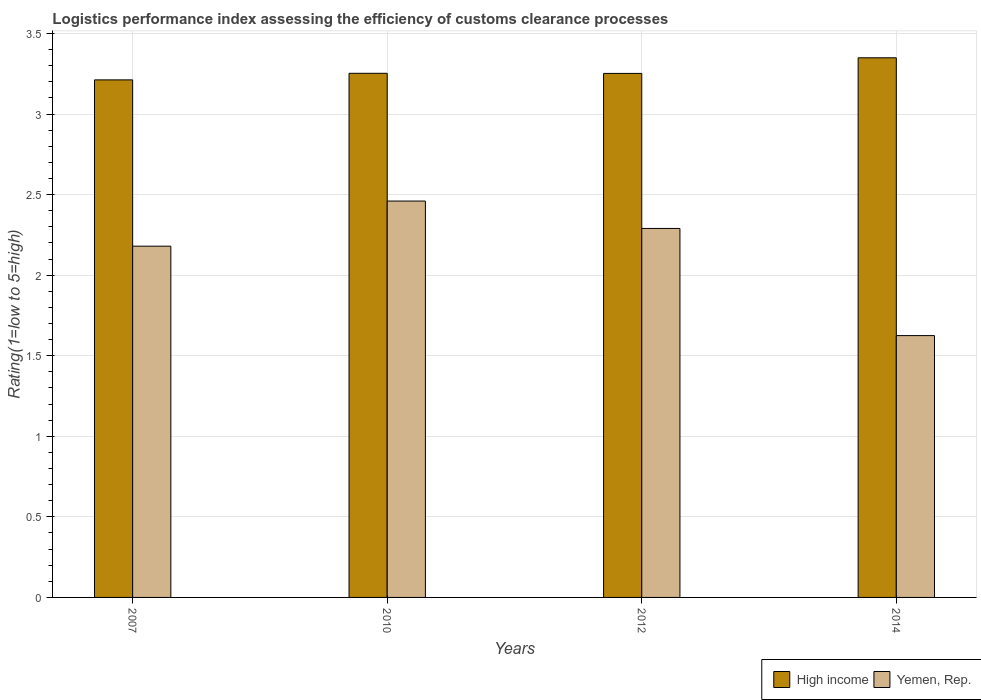How many bars are there on the 1st tick from the right?
Your response must be concise. 2. In how many cases, is the number of bars for a given year not equal to the number of legend labels?
Offer a terse response. 0. What is the Logistic performance index in Yemen, Rep. in 2007?
Offer a very short reply. 2.18. Across all years, what is the maximum Logistic performance index in Yemen, Rep.?
Give a very brief answer. 2.46. Across all years, what is the minimum Logistic performance index in Yemen, Rep.?
Provide a succinct answer. 1.62. In which year was the Logistic performance index in Yemen, Rep. maximum?
Your answer should be compact. 2010. What is the total Logistic performance index in Yemen, Rep. in the graph?
Give a very brief answer. 8.55. What is the difference between the Logistic performance index in Yemen, Rep. in 2010 and that in 2012?
Make the answer very short. 0.17. What is the difference between the Logistic performance index in Yemen, Rep. in 2010 and the Logistic performance index in High income in 2012?
Give a very brief answer. -0.79. What is the average Logistic performance index in High income per year?
Make the answer very short. 3.27. In the year 2014, what is the difference between the Logistic performance index in Yemen, Rep. and Logistic performance index in High income?
Keep it short and to the point. -1.72. What is the ratio of the Logistic performance index in High income in 2007 to that in 2010?
Provide a short and direct response. 0.99. Is the Logistic performance index in Yemen, Rep. in 2007 less than that in 2014?
Provide a succinct answer. No. What is the difference between the highest and the second highest Logistic performance index in High income?
Give a very brief answer. 0.1. What is the difference between the highest and the lowest Logistic performance index in Yemen, Rep.?
Ensure brevity in your answer.  0.83. In how many years, is the Logistic performance index in Yemen, Rep. greater than the average Logistic performance index in Yemen, Rep. taken over all years?
Provide a succinct answer. 3. Is the sum of the Logistic performance index in Yemen, Rep. in 2007 and 2014 greater than the maximum Logistic performance index in High income across all years?
Offer a terse response. Yes. What does the 2nd bar from the left in 2014 represents?
Ensure brevity in your answer.  Yemen, Rep. What does the 1st bar from the right in 2010 represents?
Your answer should be compact. Yemen, Rep. How many years are there in the graph?
Provide a short and direct response. 4. Does the graph contain any zero values?
Make the answer very short. No. Does the graph contain grids?
Ensure brevity in your answer.  Yes. Where does the legend appear in the graph?
Your answer should be compact. Bottom right. How many legend labels are there?
Provide a succinct answer. 2. How are the legend labels stacked?
Your response must be concise. Horizontal. What is the title of the graph?
Your answer should be very brief. Logistics performance index assessing the efficiency of customs clearance processes. What is the label or title of the X-axis?
Make the answer very short. Years. What is the label or title of the Y-axis?
Keep it short and to the point. Rating(1=low to 5=high). What is the Rating(1=low to 5=high) of High income in 2007?
Your answer should be compact. 3.21. What is the Rating(1=low to 5=high) in Yemen, Rep. in 2007?
Your answer should be compact. 2.18. What is the Rating(1=low to 5=high) of High income in 2010?
Your answer should be very brief. 3.25. What is the Rating(1=low to 5=high) in Yemen, Rep. in 2010?
Give a very brief answer. 2.46. What is the Rating(1=low to 5=high) of High income in 2012?
Provide a short and direct response. 3.25. What is the Rating(1=low to 5=high) of Yemen, Rep. in 2012?
Keep it short and to the point. 2.29. What is the Rating(1=low to 5=high) of High income in 2014?
Your response must be concise. 3.35. What is the Rating(1=low to 5=high) in Yemen, Rep. in 2014?
Your answer should be compact. 1.62. Across all years, what is the maximum Rating(1=low to 5=high) in High income?
Provide a short and direct response. 3.35. Across all years, what is the maximum Rating(1=low to 5=high) of Yemen, Rep.?
Ensure brevity in your answer.  2.46. Across all years, what is the minimum Rating(1=low to 5=high) of High income?
Provide a short and direct response. 3.21. Across all years, what is the minimum Rating(1=low to 5=high) of Yemen, Rep.?
Provide a short and direct response. 1.62. What is the total Rating(1=low to 5=high) of High income in the graph?
Your answer should be compact. 13.07. What is the total Rating(1=low to 5=high) of Yemen, Rep. in the graph?
Your answer should be compact. 8.55. What is the difference between the Rating(1=low to 5=high) in High income in 2007 and that in 2010?
Ensure brevity in your answer.  -0.04. What is the difference between the Rating(1=low to 5=high) of Yemen, Rep. in 2007 and that in 2010?
Your response must be concise. -0.28. What is the difference between the Rating(1=low to 5=high) of High income in 2007 and that in 2012?
Ensure brevity in your answer.  -0.04. What is the difference between the Rating(1=low to 5=high) of Yemen, Rep. in 2007 and that in 2012?
Keep it short and to the point. -0.11. What is the difference between the Rating(1=low to 5=high) in High income in 2007 and that in 2014?
Keep it short and to the point. -0.14. What is the difference between the Rating(1=low to 5=high) of Yemen, Rep. in 2007 and that in 2014?
Your response must be concise. 0.56. What is the difference between the Rating(1=low to 5=high) in High income in 2010 and that in 2012?
Provide a succinct answer. 0. What is the difference between the Rating(1=low to 5=high) of Yemen, Rep. in 2010 and that in 2012?
Your answer should be very brief. 0.17. What is the difference between the Rating(1=low to 5=high) of High income in 2010 and that in 2014?
Your answer should be compact. -0.1. What is the difference between the Rating(1=low to 5=high) of Yemen, Rep. in 2010 and that in 2014?
Your response must be concise. 0.83. What is the difference between the Rating(1=low to 5=high) of High income in 2012 and that in 2014?
Offer a terse response. -0.1. What is the difference between the Rating(1=low to 5=high) of Yemen, Rep. in 2012 and that in 2014?
Offer a very short reply. 0.67. What is the difference between the Rating(1=low to 5=high) in High income in 2007 and the Rating(1=low to 5=high) in Yemen, Rep. in 2010?
Provide a short and direct response. 0.75. What is the difference between the Rating(1=low to 5=high) in High income in 2007 and the Rating(1=low to 5=high) in Yemen, Rep. in 2012?
Provide a short and direct response. 0.92. What is the difference between the Rating(1=low to 5=high) in High income in 2007 and the Rating(1=low to 5=high) in Yemen, Rep. in 2014?
Ensure brevity in your answer.  1.59. What is the difference between the Rating(1=low to 5=high) in High income in 2010 and the Rating(1=low to 5=high) in Yemen, Rep. in 2012?
Make the answer very short. 0.96. What is the difference between the Rating(1=low to 5=high) in High income in 2010 and the Rating(1=low to 5=high) in Yemen, Rep. in 2014?
Offer a terse response. 1.63. What is the difference between the Rating(1=low to 5=high) of High income in 2012 and the Rating(1=low to 5=high) of Yemen, Rep. in 2014?
Your answer should be compact. 1.63. What is the average Rating(1=low to 5=high) in High income per year?
Your answer should be compact. 3.27. What is the average Rating(1=low to 5=high) of Yemen, Rep. per year?
Ensure brevity in your answer.  2.14. In the year 2007, what is the difference between the Rating(1=low to 5=high) in High income and Rating(1=low to 5=high) in Yemen, Rep.?
Make the answer very short. 1.03. In the year 2010, what is the difference between the Rating(1=low to 5=high) of High income and Rating(1=low to 5=high) of Yemen, Rep.?
Give a very brief answer. 0.79. In the year 2012, what is the difference between the Rating(1=low to 5=high) of High income and Rating(1=low to 5=high) of Yemen, Rep.?
Offer a terse response. 0.96. In the year 2014, what is the difference between the Rating(1=low to 5=high) of High income and Rating(1=low to 5=high) of Yemen, Rep.?
Keep it short and to the point. 1.72. What is the ratio of the Rating(1=low to 5=high) in High income in 2007 to that in 2010?
Your answer should be very brief. 0.99. What is the ratio of the Rating(1=low to 5=high) in Yemen, Rep. in 2007 to that in 2010?
Make the answer very short. 0.89. What is the ratio of the Rating(1=low to 5=high) in High income in 2007 to that in 2014?
Keep it short and to the point. 0.96. What is the ratio of the Rating(1=low to 5=high) of Yemen, Rep. in 2007 to that in 2014?
Offer a terse response. 1.34. What is the ratio of the Rating(1=low to 5=high) of High income in 2010 to that in 2012?
Provide a short and direct response. 1. What is the ratio of the Rating(1=low to 5=high) in Yemen, Rep. in 2010 to that in 2012?
Keep it short and to the point. 1.07. What is the ratio of the Rating(1=low to 5=high) of High income in 2010 to that in 2014?
Keep it short and to the point. 0.97. What is the ratio of the Rating(1=low to 5=high) of Yemen, Rep. in 2010 to that in 2014?
Offer a very short reply. 1.51. What is the ratio of the Rating(1=low to 5=high) in High income in 2012 to that in 2014?
Give a very brief answer. 0.97. What is the ratio of the Rating(1=low to 5=high) in Yemen, Rep. in 2012 to that in 2014?
Your answer should be very brief. 1.41. What is the difference between the highest and the second highest Rating(1=low to 5=high) of High income?
Keep it short and to the point. 0.1. What is the difference between the highest and the second highest Rating(1=low to 5=high) in Yemen, Rep.?
Your answer should be compact. 0.17. What is the difference between the highest and the lowest Rating(1=low to 5=high) of High income?
Offer a very short reply. 0.14. What is the difference between the highest and the lowest Rating(1=low to 5=high) of Yemen, Rep.?
Provide a short and direct response. 0.83. 